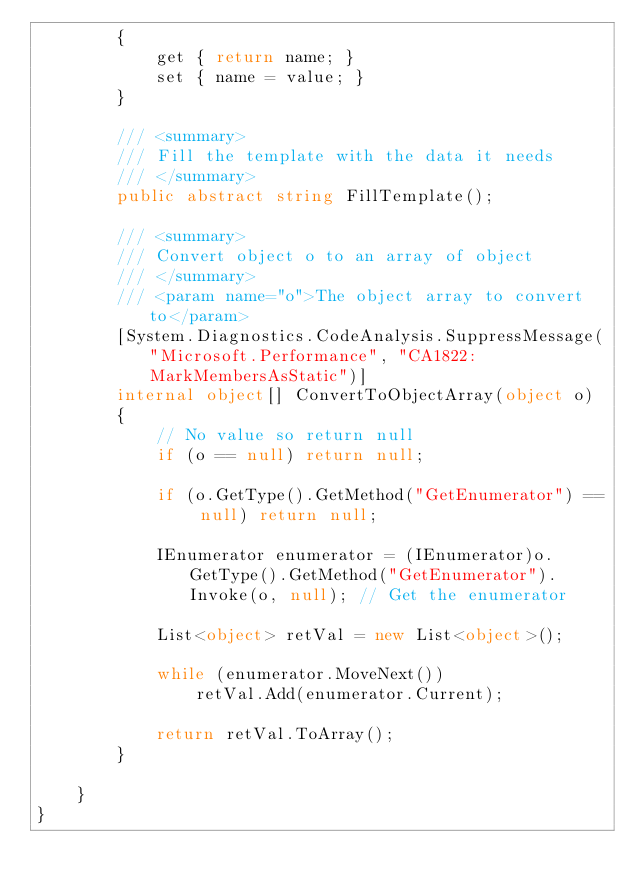<code> <loc_0><loc_0><loc_500><loc_500><_C#_>        {
            get { return name; }
            set { name = value; }
        }

        /// <summary>
        /// Fill the template with the data it needs
        /// </summary>
        public abstract string FillTemplate();

        /// <summary>
        /// Convert object o to an array of object
        /// </summary>
        /// <param name="o">The object array to convert to</param>
        [System.Diagnostics.CodeAnalysis.SuppressMessage("Microsoft.Performance", "CA1822:MarkMembersAsStatic")]
        internal object[] ConvertToObjectArray(object o)
        {
            // No value so return null
            if (o == null) return null;

            if (o.GetType().GetMethod("GetEnumerator") == null) return null;

            IEnumerator enumerator = (IEnumerator)o.GetType().GetMethod("GetEnumerator").Invoke(o, null); // Get the enumerator

            List<object> retVal = new List<object>();

            while (enumerator.MoveNext())
                retVal.Add(enumerator.Current);

            return retVal.ToArray();
        }

    }
}</code> 